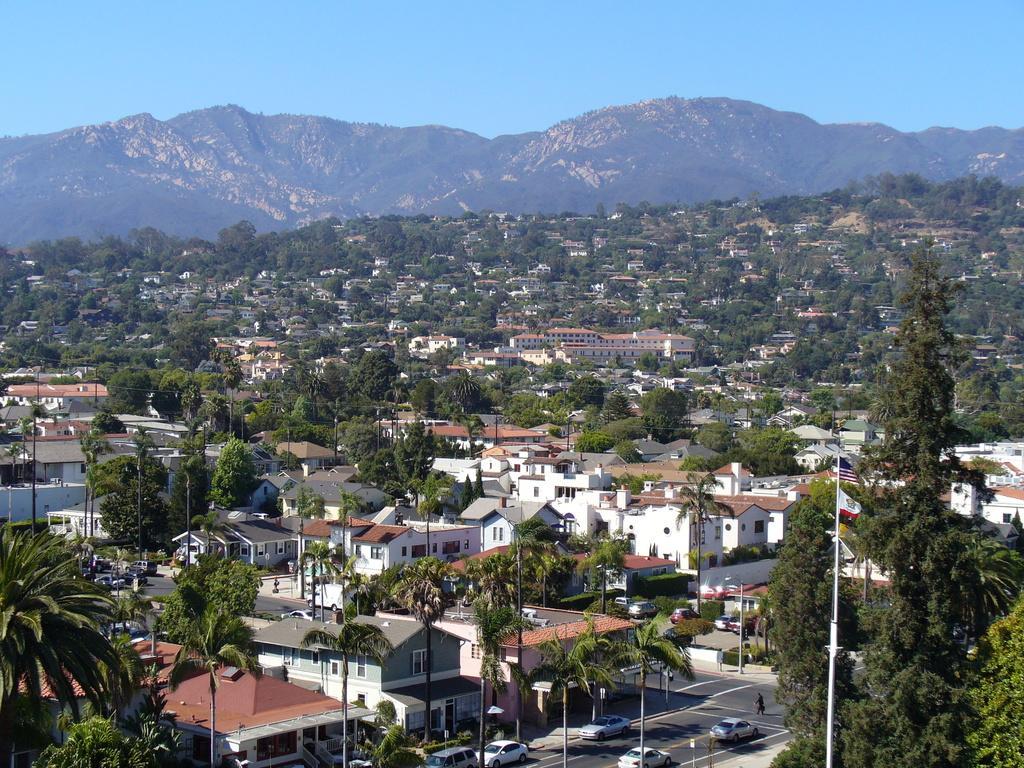Can you describe this image briefly? In this image there are vehicles on the roads, a person is walking on the road, poles, trees, buildings, houses, windows, mountains and sky. On the right side there is a flag to a pole. 